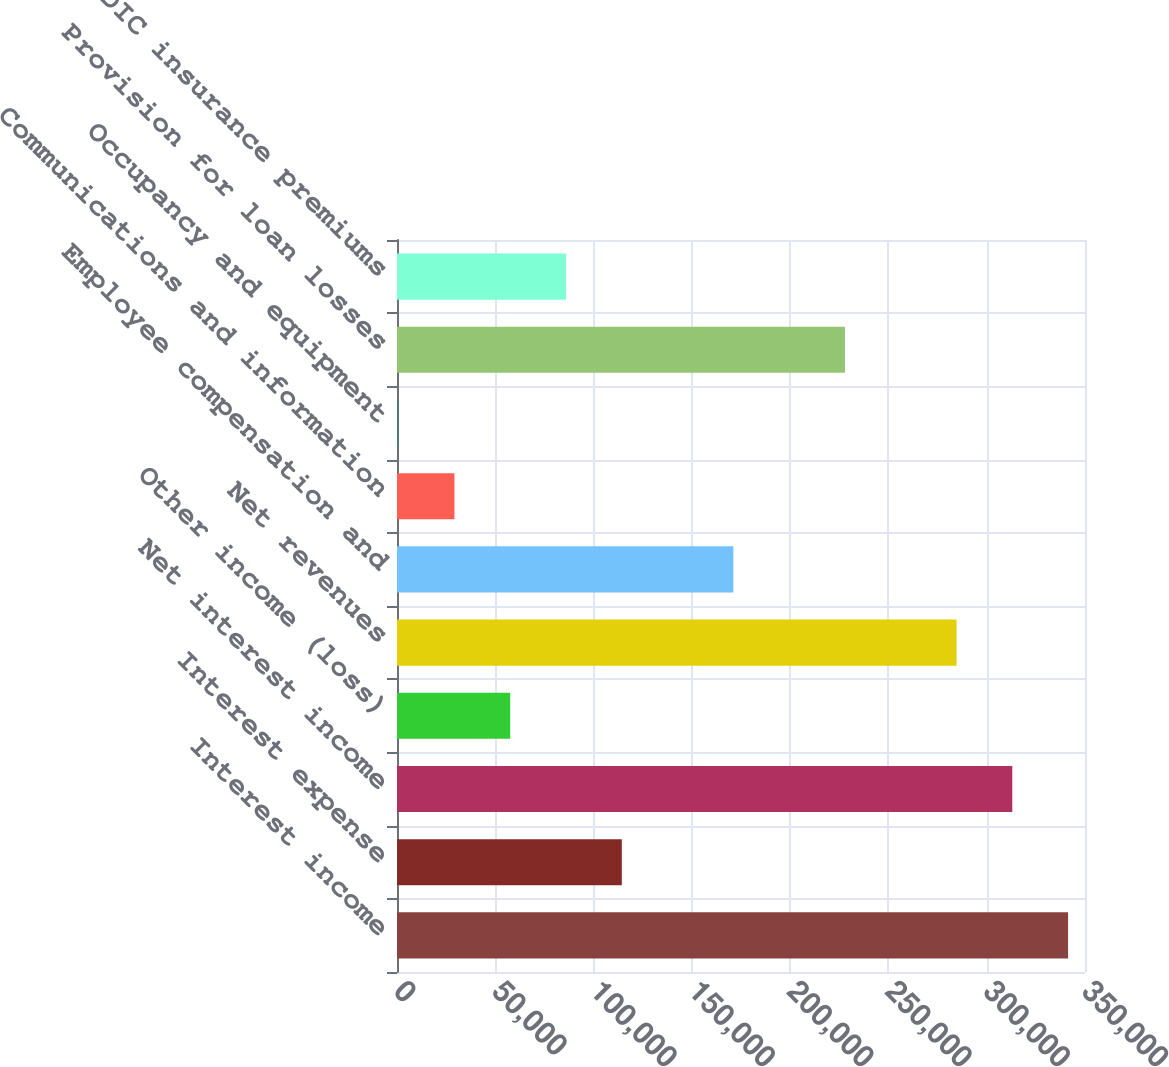Convert chart. <chart><loc_0><loc_0><loc_500><loc_500><bar_chart><fcel>Interest income<fcel>Interest expense<fcel>Net interest income<fcel>Other income (loss)<fcel>Net revenues<fcel>Employee compensation and<fcel>Communications and information<fcel>Occupancy and equipment<fcel>Provision for loan losses<fcel>FDIC insurance premiums<nl><fcel>341400<fcel>114361<fcel>313020<fcel>57601.6<fcel>284640<fcel>171121<fcel>29221.8<fcel>842<fcel>227880<fcel>85981.4<nl></chart> 